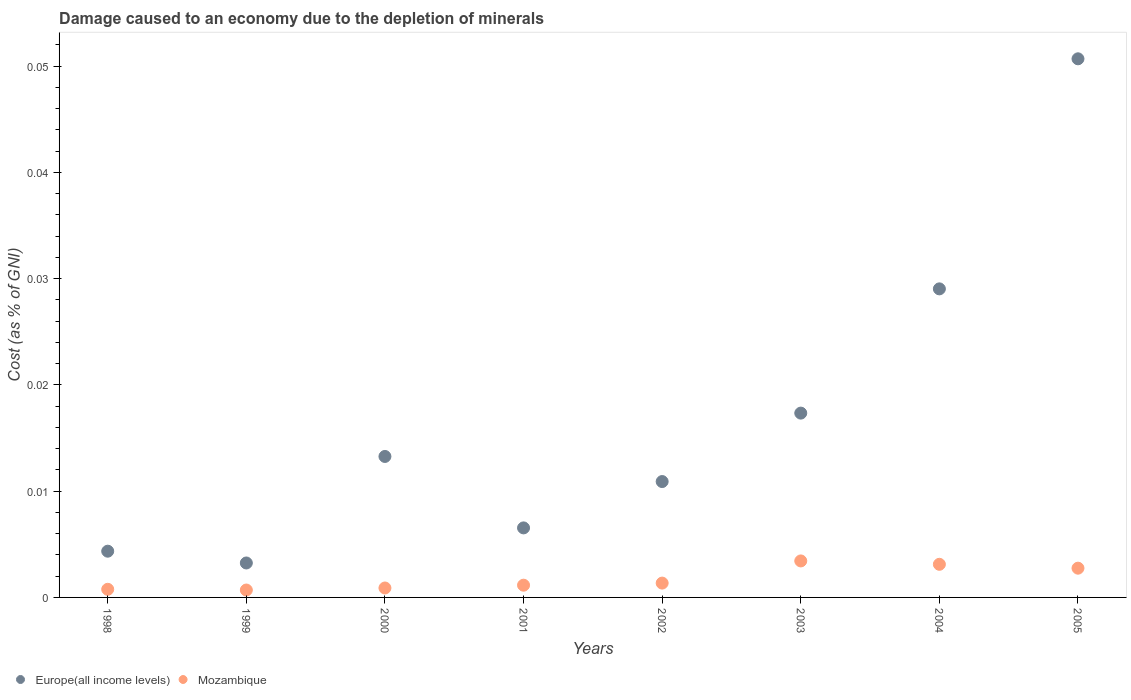How many different coloured dotlines are there?
Make the answer very short. 2. Is the number of dotlines equal to the number of legend labels?
Make the answer very short. Yes. What is the cost of damage caused due to the depletion of minerals in Mozambique in 2003?
Provide a succinct answer. 0. Across all years, what is the maximum cost of damage caused due to the depletion of minerals in Europe(all income levels)?
Your answer should be very brief. 0.05. Across all years, what is the minimum cost of damage caused due to the depletion of minerals in Mozambique?
Make the answer very short. 0. In which year was the cost of damage caused due to the depletion of minerals in Mozambique maximum?
Ensure brevity in your answer.  2003. In which year was the cost of damage caused due to the depletion of minerals in Mozambique minimum?
Your answer should be compact. 1999. What is the total cost of damage caused due to the depletion of minerals in Mozambique in the graph?
Offer a very short reply. 0.01. What is the difference between the cost of damage caused due to the depletion of minerals in Mozambique in 1998 and that in 2002?
Provide a succinct answer. -0. What is the difference between the cost of damage caused due to the depletion of minerals in Mozambique in 1998 and the cost of damage caused due to the depletion of minerals in Europe(all income levels) in 2004?
Give a very brief answer. -0.03. What is the average cost of damage caused due to the depletion of minerals in Europe(all income levels) per year?
Your answer should be very brief. 0.02. In the year 2000, what is the difference between the cost of damage caused due to the depletion of minerals in Europe(all income levels) and cost of damage caused due to the depletion of minerals in Mozambique?
Ensure brevity in your answer.  0.01. In how many years, is the cost of damage caused due to the depletion of minerals in Europe(all income levels) greater than 0.022 %?
Give a very brief answer. 2. What is the ratio of the cost of damage caused due to the depletion of minerals in Mozambique in 2001 to that in 2003?
Your answer should be compact. 0.34. Is the cost of damage caused due to the depletion of minerals in Mozambique in 1998 less than that in 2004?
Keep it short and to the point. Yes. Is the difference between the cost of damage caused due to the depletion of minerals in Europe(all income levels) in 1999 and 2003 greater than the difference between the cost of damage caused due to the depletion of minerals in Mozambique in 1999 and 2003?
Offer a very short reply. No. What is the difference between the highest and the second highest cost of damage caused due to the depletion of minerals in Europe(all income levels)?
Your answer should be very brief. 0.02. What is the difference between the highest and the lowest cost of damage caused due to the depletion of minerals in Mozambique?
Your answer should be very brief. 0. In how many years, is the cost of damage caused due to the depletion of minerals in Europe(all income levels) greater than the average cost of damage caused due to the depletion of minerals in Europe(all income levels) taken over all years?
Offer a very short reply. 3. Is the cost of damage caused due to the depletion of minerals in Europe(all income levels) strictly greater than the cost of damage caused due to the depletion of minerals in Mozambique over the years?
Your answer should be very brief. Yes. Is the cost of damage caused due to the depletion of minerals in Europe(all income levels) strictly less than the cost of damage caused due to the depletion of minerals in Mozambique over the years?
Make the answer very short. No. How many dotlines are there?
Ensure brevity in your answer.  2. How many years are there in the graph?
Your answer should be very brief. 8. What is the difference between two consecutive major ticks on the Y-axis?
Offer a terse response. 0.01. Does the graph contain grids?
Give a very brief answer. No. What is the title of the graph?
Offer a very short reply. Damage caused to an economy due to the depletion of minerals. Does "Monaco" appear as one of the legend labels in the graph?
Keep it short and to the point. No. What is the label or title of the X-axis?
Keep it short and to the point. Years. What is the label or title of the Y-axis?
Make the answer very short. Cost (as % of GNI). What is the Cost (as % of GNI) in Europe(all income levels) in 1998?
Ensure brevity in your answer.  0. What is the Cost (as % of GNI) of Mozambique in 1998?
Provide a succinct answer. 0. What is the Cost (as % of GNI) of Europe(all income levels) in 1999?
Give a very brief answer. 0. What is the Cost (as % of GNI) in Mozambique in 1999?
Provide a short and direct response. 0. What is the Cost (as % of GNI) of Europe(all income levels) in 2000?
Your answer should be compact. 0.01. What is the Cost (as % of GNI) of Mozambique in 2000?
Provide a succinct answer. 0. What is the Cost (as % of GNI) of Europe(all income levels) in 2001?
Provide a short and direct response. 0.01. What is the Cost (as % of GNI) in Mozambique in 2001?
Ensure brevity in your answer.  0. What is the Cost (as % of GNI) of Europe(all income levels) in 2002?
Offer a very short reply. 0.01. What is the Cost (as % of GNI) of Mozambique in 2002?
Offer a terse response. 0. What is the Cost (as % of GNI) of Europe(all income levels) in 2003?
Offer a terse response. 0.02. What is the Cost (as % of GNI) in Mozambique in 2003?
Give a very brief answer. 0. What is the Cost (as % of GNI) of Europe(all income levels) in 2004?
Offer a very short reply. 0.03. What is the Cost (as % of GNI) in Mozambique in 2004?
Offer a terse response. 0. What is the Cost (as % of GNI) in Europe(all income levels) in 2005?
Offer a very short reply. 0.05. What is the Cost (as % of GNI) of Mozambique in 2005?
Make the answer very short. 0. Across all years, what is the maximum Cost (as % of GNI) of Europe(all income levels)?
Provide a short and direct response. 0.05. Across all years, what is the maximum Cost (as % of GNI) of Mozambique?
Offer a very short reply. 0. Across all years, what is the minimum Cost (as % of GNI) in Europe(all income levels)?
Provide a short and direct response. 0. Across all years, what is the minimum Cost (as % of GNI) in Mozambique?
Give a very brief answer. 0. What is the total Cost (as % of GNI) of Europe(all income levels) in the graph?
Your answer should be very brief. 0.14. What is the total Cost (as % of GNI) of Mozambique in the graph?
Your answer should be very brief. 0.01. What is the difference between the Cost (as % of GNI) in Europe(all income levels) in 1998 and that in 1999?
Your answer should be very brief. 0. What is the difference between the Cost (as % of GNI) of Europe(all income levels) in 1998 and that in 2000?
Your answer should be compact. -0.01. What is the difference between the Cost (as % of GNI) of Mozambique in 1998 and that in 2000?
Make the answer very short. -0. What is the difference between the Cost (as % of GNI) in Europe(all income levels) in 1998 and that in 2001?
Your answer should be very brief. -0. What is the difference between the Cost (as % of GNI) of Mozambique in 1998 and that in 2001?
Provide a succinct answer. -0. What is the difference between the Cost (as % of GNI) of Europe(all income levels) in 1998 and that in 2002?
Your answer should be compact. -0.01. What is the difference between the Cost (as % of GNI) of Mozambique in 1998 and that in 2002?
Your answer should be compact. -0. What is the difference between the Cost (as % of GNI) of Europe(all income levels) in 1998 and that in 2003?
Make the answer very short. -0.01. What is the difference between the Cost (as % of GNI) of Mozambique in 1998 and that in 2003?
Give a very brief answer. -0. What is the difference between the Cost (as % of GNI) in Europe(all income levels) in 1998 and that in 2004?
Your response must be concise. -0.02. What is the difference between the Cost (as % of GNI) in Mozambique in 1998 and that in 2004?
Provide a succinct answer. -0. What is the difference between the Cost (as % of GNI) in Europe(all income levels) in 1998 and that in 2005?
Your answer should be very brief. -0.05. What is the difference between the Cost (as % of GNI) of Mozambique in 1998 and that in 2005?
Ensure brevity in your answer.  -0. What is the difference between the Cost (as % of GNI) in Europe(all income levels) in 1999 and that in 2000?
Offer a terse response. -0.01. What is the difference between the Cost (as % of GNI) in Mozambique in 1999 and that in 2000?
Provide a short and direct response. -0. What is the difference between the Cost (as % of GNI) of Europe(all income levels) in 1999 and that in 2001?
Your answer should be very brief. -0. What is the difference between the Cost (as % of GNI) of Mozambique in 1999 and that in 2001?
Your answer should be compact. -0. What is the difference between the Cost (as % of GNI) of Europe(all income levels) in 1999 and that in 2002?
Make the answer very short. -0.01. What is the difference between the Cost (as % of GNI) in Mozambique in 1999 and that in 2002?
Ensure brevity in your answer.  -0. What is the difference between the Cost (as % of GNI) in Europe(all income levels) in 1999 and that in 2003?
Offer a very short reply. -0.01. What is the difference between the Cost (as % of GNI) of Mozambique in 1999 and that in 2003?
Your answer should be very brief. -0. What is the difference between the Cost (as % of GNI) of Europe(all income levels) in 1999 and that in 2004?
Provide a short and direct response. -0.03. What is the difference between the Cost (as % of GNI) in Mozambique in 1999 and that in 2004?
Your response must be concise. -0. What is the difference between the Cost (as % of GNI) of Europe(all income levels) in 1999 and that in 2005?
Offer a very short reply. -0.05. What is the difference between the Cost (as % of GNI) in Mozambique in 1999 and that in 2005?
Keep it short and to the point. -0. What is the difference between the Cost (as % of GNI) of Europe(all income levels) in 2000 and that in 2001?
Keep it short and to the point. 0.01. What is the difference between the Cost (as % of GNI) of Mozambique in 2000 and that in 2001?
Offer a very short reply. -0. What is the difference between the Cost (as % of GNI) in Europe(all income levels) in 2000 and that in 2002?
Your answer should be very brief. 0. What is the difference between the Cost (as % of GNI) in Mozambique in 2000 and that in 2002?
Keep it short and to the point. -0. What is the difference between the Cost (as % of GNI) in Europe(all income levels) in 2000 and that in 2003?
Make the answer very short. -0. What is the difference between the Cost (as % of GNI) of Mozambique in 2000 and that in 2003?
Provide a succinct answer. -0. What is the difference between the Cost (as % of GNI) of Europe(all income levels) in 2000 and that in 2004?
Keep it short and to the point. -0.02. What is the difference between the Cost (as % of GNI) of Mozambique in 2000 and that in 2004?
Make the answer very short. -0. What is the difference between the Cost (as % of GNI) of Europe(all income levels) in 2000 and that in 2005?
Make the answer very short. -0.04. What is the difference between the Cost (as % of GNI) of Mozambique in 2000 and that in 2005?
Your response must be concise. -0. What is the difference between the Cost (as % of GNI) in Europe(all income levels) in 2001 and that in 2002?
Your answer should be compact. -0. What is the difference between the Cost (as % of GNI) in Mozambique in 2001 and that in 2002?
Your answer should be compact. -0. What is the difference between the Cost (as % of GNI) of Europe(all income levels) in 2001 and that in 2003?
Your answer should be very brief. -0.01. What is the difference between the Cost (as % of GNI) of Mozambique in 2001 and that in 2003?
Your answer should be very brief. -0. What is the difference between the Cost (as % of GNI) in Europe(all income levels) in 2001 and that in 2004?
Offer a very short reply. -0.02. What is the difference between the Cost (as % of GNI) in Mozambique in 2001 and that in 2004?
Provide a short and direct response. -0. What is the difference between the Cost (as % of GNI) in Europe(all income levels) in 2001 and that in 2005?
Offer a terse response. -0.04. What is the difference between the Cost (as % of GNI) in Mozambique in 2001 and that in 2005?
Your response must be concise. -0. What is the difference between the Cost (as % of GNI) of Europe(all income levels) in 2002 and that in 2003?
Your answer should be compact. -0.01. What is the difference between the Cost (as % of GNI) of Mozambique in 2002 and that in 2003?
Offer a very short reply. -0. What is the difference between the Cost (as % of GNI) in Europe(all income levels) in 2002 and that in 2004?
Provide a short and direct response. -0.02. What is the difference between the Cost (as % of GNI) of Mozambique in 2002 and that in 2004?
Your answer should be compact. -0. What is the difference between the Cost (as % of GNI) of Europe(all income levels) in 2002 and that in 2005?
Your answer should be compact. -0.04. What is the difference between the Cost (as % of GNI) in Mozambique in 2002 and that in 2005?
Provide a succinct answer. -0. What is the difference between the Cost (as % of GNI) of Europe(all income levels) in 2003 and that in 2004?
Offer a terse response. -0.01. What is the difference between the Cost (as % of GNI) of Mozambique in 2003 and that in 2004?
Provide a short and direct response. 0. What is the difference between the Cost (as % of GNI) in Europe(all income levels) in 2003 and that in 2005?
Offer a very short reply. -0.03. What is the difference between the Cost (as % of GNI) in Mozambique in 2003 and that in 2005?
Provide a short and direct response. 0. What is the difference between the Cost (as % of GNI) in Europe(all income levels) in 2004 and that in 2005?
Your response must be concise. -0.02. What is the difference between the Cost (as % of GNI) in Europe(all income levels) in 1998 and the Cost (as % of GNI) in Mozambique in 1999?
Offer a very short reply. 0. What is the difference between the Cost (as % of GNI) in Europe(all income levels) in 1998 and the Cost (as % of GNI) in Mozambique in 2000?
Your answer should be compact. 0. What is the difference between the Cost (as % of GNI) of Europe(all income levels) in 1998 and the Cost (as % of GNI) of Mozambique in 2001?
Ensure brevity in your answer.  0. What is the difference between the Cost (as % of GNI) of Europe(all income levels) in 1998 and the Cost (as % of GNI) of Mozambique in 2002?
Provide a short and direct response. 0. What is the difference between the Cost (as % of GNI) in Europe(all income levels) in 1998 and the Cost (as % of GNI) in Mozambique in 2003?
Your answer should be very brief. 0. What is the difference between the Cost (as % of GNI) in Europe(all income levels) in 1998 and the Cost (as % of GNI) in Mozambique in 2004?
Provide a short and direct response. 0. What is the difference between the Cost (as % of GNI) in Europe(all income levels) in 1998 and the Cost (as % of GNI) in Mozambique in 2005?
Offer a terse response. 0. What is the difference between the Cost (as % of GNI) in Europe(all income levels) in 1999 and the Cost (as % of GNI) in Mozambique in 2000?
Your answer should be compact. 0. What is the difference between the Cost (as % of GNI) of Europe(all income levels) in 1999 and the Cost (as % of GNI) of Mozambique in 2001?
Give a very brief answer. 0. What is the difference between the Cost (as % of GNI) of Europe(all income levels) in 1999 and the Cost (as % of GNI) of Mozambique in 2002?
Keep it short and to the point. 0. What is the difference between the Cost (as % of GNI) of Europe(all income levels) in 1999 and the Cost (as % of GNI) of Mozambique in 2003?
Your response must be concise. -0. What is the difference between the Cost (as % of GNI) in Europe(all income levels) in 1999 and the Cost (as % of GNI) in Mozambique in 2004?
Your answer should be compact. 0. What is the difference between the Cost (as % of GNI) in Europe(all income levels) in 1999 and the Cost (as % of GNI) in Mozambique in 2005?
Give a very brief answer. 0. What is the difference between the Cost (as % of GNI) of Europe(all income levels) in 2000 and the Cost (as % of GNI) of Mozambique in 2001?
Give a very brief answer. 0.01. What is the difference between the Cost (as % of GNI) of Europe(all income levels) in 2000 and the Cost (as % of GNI) of Mozambique in 2002?
Give a very brief answer. 0.01. What is the difference between the Cost (as % of GNI) in Europe(all income levels) in 2000 and the Cost (as % of GNI) in Mozambique in 2003?
Provide a succinct answer. 0.01. What is the difference between the Cost (as % of GNI) of Europe(all income levels) in 2000 and the Cost (as % of GNI) of Mozambique in 2004?
Your answer should be very brief. 0.01. What is the difference between the Cost (as % of GNI) in Europe(all income levels) in 2000 and the Cost (as % of GNI) in Mozambique in 2005?
Offer a very short reply. 0.01. What is the difference between the Cost (as % of GNI) in Europe(all income levels) in 2001 and the Cost (as % of GNI) in Mozambique in 2002?
Provide a succinct answer. 0.01. What is the difference between the Cost (as % of GNI) in Europe(all income levels) in 2001 and the Cost (as % of GNI) in Mozambique in 2003?
Offer a terse response. 0. What is the difference between the Cost (as % of GNI) in Europe(all income levels) in 2001 and the Cost (as % of GNI) in Mozambique in 2004?
Your answer should be very brief. 0. What is the difference between the Cost (as % of GNI) in Europe(all income levels) in 2001 and the Cost (as % of GNI) in Mozambique in 2005?
Make the answer very short. 0. What is the difference between the Cost (as % of GNI) of Europe(all income levels) in 2002 and the Cost (as % of GNI) of Mozambique in 2003?
Offer a terse response. 0.01. What is the difference between the Cost (as % of GNI) in Europe(all income levels) in 2002 and the Cost (as % of GNI) in Mozambique in 2004?
Make the answer very short. 0.01. What is the difference between the Cost (as % of GNI) of Europe(all income levels) in 2002 and the Cost (as % of GNI) of Mozambique in 2005?
Make the answer very short. 0.01. What is the difference between the Cost (as % of GNI) of Europe(all income levels) in 2003 and the Cost (as % of GNI) of Mozambique in 2004?
Your response must be concise. 0.01. What is the difference between the Cost (as % of GNI) in Europe(all income levels) in 2003 and the Cost (as % of GNI) in Mozambique in 2005?
Your answer should be very brief. 0.01. What is the difference between the Cost (as % of GNI) of Europe(all income levels) in 2004 and the Cost (as % of GNI) of Mozambique in 2005?
Your response must be concise. 0.03. What is the average Cost (as % of GNI) of Europe(all income levels) per year?
Provide a short and direct response. 0.02. What is the average Cost (as % of GNI) of Mozambique per year?
Your answer should be compact. 0. In the year 1998, what is the difference between the Cost (as % of GNI) of Europe(all income levels) and Cost (as % of GNI) of Mozambique?
Offer a very short reply. 0. In the year 1999, what is the difference between the Cost (as % of GNI) in Europe(all income levels) and Cost (as % of GNI) in Mozambique?
Offer a very short reply. 0. In the year 2000, what is the difference between the Cost (as % of GNI) of Europe(all income levels) and Cost (as % of GNI) of Mozambique?
Your response must be concise. 0.01. In the year 2001, what is the difference between the Cost (as % of GNI) in Europe(all income levels) and Cost (as % of GNI) in Mozambique?
Provide a short and direct response. 0.01. In the year 2002, what is the difference between the Cost (as % of GNI) of Europe(all income levels) and Cost (as % of GNI) of Mozambique?
Offer a terse response. 0.01. In the year 2003, what is the difference between the Cost (as % of GNI) in Europe(all income levels) and Cost (as % of GNI) in Mozambique?
Your response must be concise. 0.01. In the year 2004, what is the difference between the Cost (as % of GNI) in Europe(all income levels) and Cost (as % of GNI) in Mozambique?
Offer a very short reply. 0.03. In the year 2005, what is the difference between the Cost (as % of GNI) in Europe(all income levels) and Cost (as % of GNI) in Mozambique?
Your answer should be compact. 0.05. What is the ratio of the Cost (as % of GNI) in Europe(all income levels) in 1998 to that in 1999?
Your answer should be very brief. 1.34. What is the ratio of the Cost (as % of GNI) in Mozambique in 1998 to that in 1999?
Offer a very short reply. 1.1. What is the ratio of the Cost (as % of GNI) of Europe(all income levels) in 1998 to that in 2000?
Give a very brief answer. 0.33. What is the ratio of the Cost (as % of GNI) of Mozambique in 1998 to that in 2000?
Provide a short and direct response. 0.86. What is the ratio of the Cost (as % of GNI) of Europe(all income levels) in 1998 to that in 2001?
Keep it short and to the point. 0.66. What is the ratio of the Cost (as % of GNI) in Mozambique in 1998 to that in 2001?
Offer a very short reply. 0.66. What is the ratio of the Cost (as % of GNI) in Europe(all income levels) in 1998 to that in 2002?
Offer a very short reply. 0.4. What is the ratio of the Cost (as % of GNI) in Mozambique in 1998 to that in 2002?
Offer a terse response. 0.57. What is the ratio of the Cost (as % of GNI) in Europe(all income levels) in 1998 to that in 2003?
Provide a succinct answer. 0.25. What is the ratio of the Cost (as % of GNI) of Mozambique in 1998 to that in 2003?
Your answer should be very brief. 0.22. What is the ratio of the Cost (as % of GNI) in Europe(all income levels) in 1998 to that in 2004?
Keep it short and to the point. 0.15. What is the ratio of the Cost (as % of GNI) of Mozambique in 1998 to that in 2004?
Keep it short and to the point. 0.25. What is the ratio of the Cost (as % of GNI) in Europe(all income levels) in 1998 to that in 2005?
Make the answer very short. 0.09. What is the ratio of the Cost (as % of GNI) of Mozambique in 1998 to that in 2005?
Keep it short and to the point. 0.28. What is the ratio of the Cost (as % of GNI) in Europe(all income levels) in 1999 to that in 2000?
Ensure brevity in your answer.  0.24. What is the ratio of the Cost (as % of GNI) in Mozambique in 1999 to that in 2000?
Offer a very short reply. 0.78. What is the ratio of the Cost (as % of GNI) in Europe(all income levels) in 1999 to that in 2001?
Offer a terse response. 0.5. What is the ratio of the Cost (as % of GNI) in Mozambique in 1999 to that in 2001?
Offer a terse response. 0.6. What is the ratio of the Cost (as % of GNI) of Europe(all income levels) in 1999 to that in 2002?
Offer a very short reply. 0.3. What is the ratio of the Cost (as % of GNI) in Mozambique in 1999 to that in 2002?
Your response must be concise. 0.52. What is the ratio of the Cost (as % of GNI) of Europe(all income levels) in 1999 to that in 2003?
Make the answer very short. 0.19. What is the ratio of the Cost (as % of GNI) in Mozambique in 1999 to that in 2003?
Offer a very short reply. 0.2. What is the ratio of the Cost (as % of GNI) in Europe(all income levels) in 1999 to that in 2004?
Your answer should be very brief. 0.11. What is the ratio of the Cost (as % of GNI) in Mozambique in 1999 to that in 2004?
Provide a short and direct response. 0.22. What is the ratio of the Cost (as % of GNI) in Europe(all income levels) in 1999 to that in 2005?
Give a very brief answer. 0.06. What is the ratio of the Cost (as % of GNI) in Mozambique in 1999 to that in 2005?
Keep it short and to the point. 0.25. What is the ratio of the Cost (as % of GNI) of Europe(all income levels) in 2000 to that in 2001?
Provide a succinct answer. 2.03. What is the ratio of the Cost (as % of GNI) of Mozambique in 2000 to that in 2001?
Make the answer very short. 0.77. What is the ratio of the Cost (as % of GNI) of Europe(all income levels) in 2000 to that in 2002?
Offer a very short reply. 1.22. What is the ratio of the Cost (as % of GNI) in Mozambique in 2000 to that in 2002?
Your answer should be very brief. 0.66. What is the ratio of the Cost (as % of GNI) of Europe(all income levels) in 2000 to that in 2003?
Give a very brief answer. 0.76. What is the ratio of the Cost (as % of GNI) of Mozambique in 2000 to that in 2003?
Make the answer very short. 0.26. What is the ratio of the Cost (as % of GNI) of Europe(all income levels) in 2000 to that in 2004?
Make the answer very short. 0.46. What is the ratio of the Cost (as % of GNI) in Mozambique in 2000 to that in 2004?
Keep it short and to the point. 0.28. What is the ratio of the Cost (as % of GNI) of Europe(all income levels) in 2000 to that in 2005?
Ensure brevity in your answer.  0.26. What is the ratio of the Cost (as % of GNI) of Mozambique in 2000 to that in 2005?
Provide a succinct answer. 0.32. What is the ratio of the Cost (as % of GNI) in Europe(all income levels) in 2001 to that in 2002?
Provide a short and direct response. 0.6. What is the ratio of the Cost (as % of GNI) in Mozambique in 2001 to that in 2002?
Give a very brief answer. 0.85. What is the ratio of the Cost (as % of GNI) in Europe(all income levels) in 2001 to that in 2003?
Keep it short and to the point. 0.38. What is the ratio of the Cost (as % of GNI) in Mozambique in 2001 to that in 2003?
Give a very brief answer. 0.34. What is the ratio of the Cost (as % of GNI) of Europe(all income levels) in 2001 to that in 2004?
Your answer should be very brief. 0.23. What is the ratio of the Cost (as % of GNI) in Mozambique in 2001 to that in 2004?
Offer a very short reply. 0.37. What is the ratio of the Cost (as % of GNI) in Europe(all income levels) in 2001 to that in 2005?
Keep it short and to the point. 0.13. What is the ratio of the Cost (as % of GNI) of Mozambique in 2001 to that in 2005?
Provide a short and direct response. 0.42. What is the ratio of the Cost (as % of GNI) of Europe(all income levels) in 2002 to that in 2003?
Your response must be concise. 0.63. What is the ratio of the Cost (as % of GNI) of Mozambique in 2002 to that in 2003?
Offer a very short reply. 0.39. What is the ratio of the Cost (as % of GNI) of Europe(all income levels) in 2002 to that in 2004?
Your answer should be compact. 0.38. What is the ratio of the Cost (as % of GNI) in Mozambique in 2002 to that in 2004?
Offer a terse response. 0.43. What is the ratio of the Cost (as % of GNI) in Europe(all income levels) in 2002 to that in 2005?
Keep it short and to the point. 0.22. What is the ratio of the Cost (as % of GNI) in Mozambique in 2002 to that in 2005?
Your answer should be compact. 0.49. What is the ratio of the Cost (as % of GNI) in Europe(all income levels) in 2003 to that in 2004?
Your response must be concise. 0.6. What is the ratio of the Cost (as % of GNI) of Mozambique in 2003 to that in 2004?
Provide a short and direct response. 1.1. What is the ratio of the Cost (as % of GNI) of Europe(all income levels) in 2003 to that in 2005?
Make the answer very short. 0.34. What is the ratio of the Cost (as % of GNI) of Mozambique in 2003 to that in 2005?
Your answer should be very brief. 1.25. What is the ratio of the Cost (as % of GNI) of Europe(all income levels) in 2004 to that in 2005?
Your answer should be very brief. 0.57. What is the ratio of the Cost (as % of GNI) in Mozambique in 2004 to that in 2005?
Keep it short and to the point. 1.13. What is the difference between the highest and the second highest Cost (as % of GNI) of Europe(all income levels)?
Offer a terse response. 0.02. What is the difference between the highest and the lowest Cost (as % of GNI) of Europe(all income levels)?
Your answer should be very brief. 0.05. What is the difference between the highest and the lowest Cost (as % of GNI) in Mozambique?
Ensure brevity in your answer.  0. 